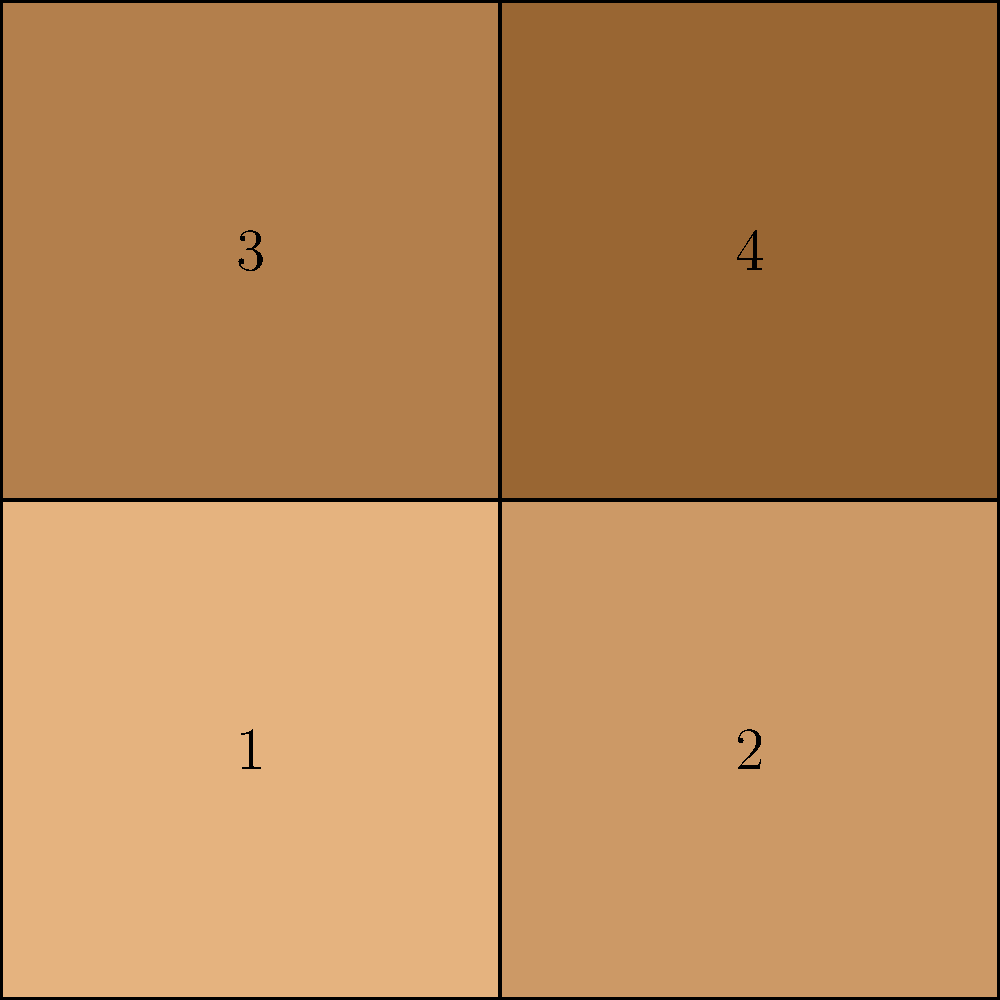As a photo restoration expert, you're tasked with reconstructing a torn photograph. The image above represents four puzzle-like pieces of the photo. Which sequence of piece numbers, when arranged from top-left to bottom-right, would correctly reconstruct the original photograph? To reconstruct the photograph, we need to analyze the shading and edges of each piece:

1. Observe that the shading gets darker from left to right and top to bottom.
2. Piece 1 is the lightest, so it should be in the top-left corner.
3. Piece 2 is slightly darker than piece 1 and matches the right edge of piece 1, so it goes to the right of piece 1.
4. Piece 3 is darker than piece 1 but lighter than piece 4, and it matches the bottom edge of piece 1, so it goes below piece 1.
5. Piece 4 is the darkest and fits in the remaining bottom-right corner, matching the right edge of piece 3 and the bottom edge of piece 2.

Therefore, the correct sequence from top-left to bottom-right is:
1 (top-left), 2 (top-right), 3 (bottom-left), 4 (bottom-right).
Answer: 1, 2, 3, 4 